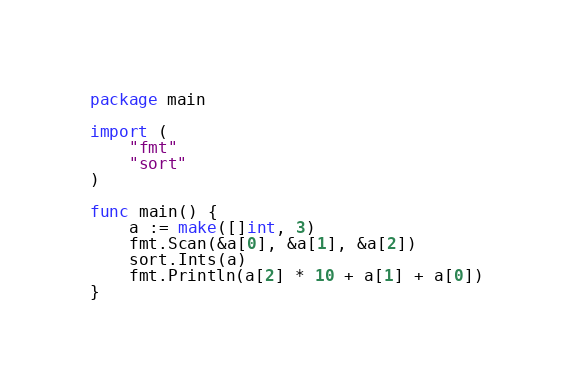<code> <loc_0><loc_0><loc_500><loc_500><_Go_>package main

import (
	"fmt"
	"sort"
)

func main() {
	a := make([]int, 3)
	fmt.Scan(&a[0], &a[1], &a[2])
	sort.Ints(a)
	fmt.Println(a[2] * 10 + a[1] + a[0])
}</code> 